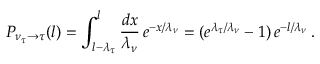<formula> <loc_0><loc_0><loc_500><loc_500>P _ { { \nu _ { \tau } } \rightarrow \tau } ( l ) = \int _ { l - \lambda _ { \tau } } ^ { l } \frac { d x } { \lambda _ { \nu } } \, e ^ { - x / \lambda _ { \nu } } = ( e ^ { \lambda _ { \tau } / \lambda _ { \nu } } - 1 ) \, e ^ { - l / \lambda _ { \nu } } \, .</formula> 